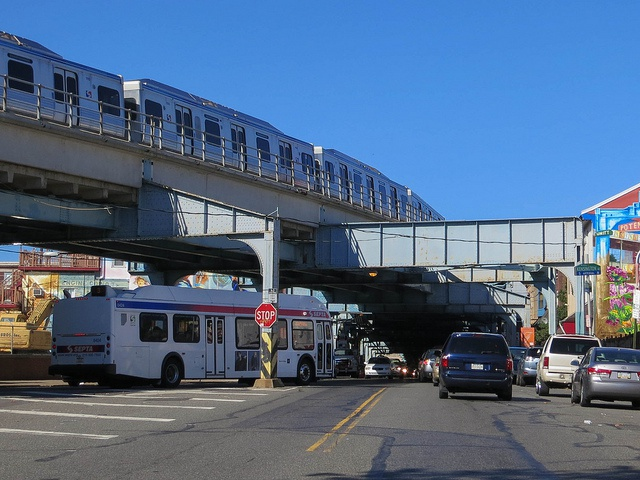Describe the objects in this image and their specific colors. I can see train in gray, black, and navy tones, bus in gray, black, and navy tones, car in gray, black, navy, and maroon tones, car in gray, black, darkgray, and navy tones, and car in gray, black, lightgray, and darkgray tones in this image. 